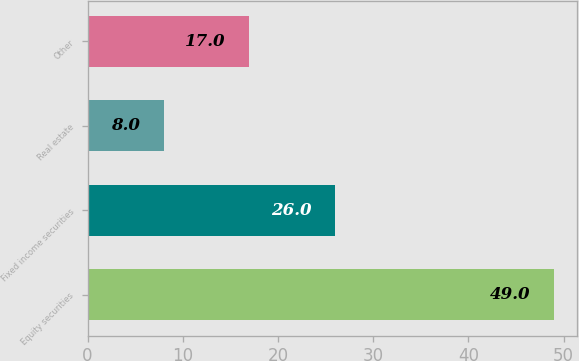Convert chart. <chart><loc_0><loc_0><loc_500><loc_500><bar_chart><fcel>Equity securities<fcel>Fixed income securities<fcel>Real estate<fcel>Other<nl><fcel>49<fcel>26<fcel>8<fcel>17<nl></chart> 